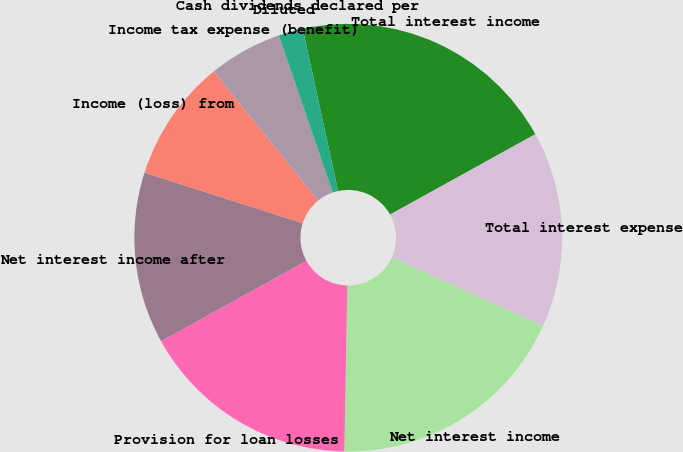Convert chart. <chart><loc_0><loc_0><loc_500><loc_500><pie_chart><fcel>Total interest income<fcel>Total interest expense<fcel>Net interest income<fcel>Provision for loan losses<fcel>Net interest income after<fcel>Income (loss) from<fcel>Income tax expense (benefit)<fcel>Diluted<fcel>Cash dividends declared per<nl><fcel>20.37%<fcel>14.81%<fcel>18.52%<fcel>16.67%<fcel>12.96%<fcel>9.26%<fcel>5.56%<fcel>1.85%<fcel>0.0%<nl></chart> 